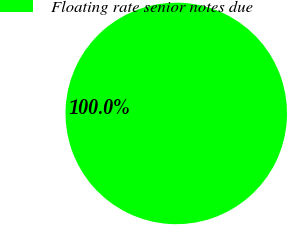<chart> <loc_0><loc_0><loc_500><loc_500><pie_chart><fcel>Floating rate senior notes due<nl><fcel>100.0%<nl></chart> 